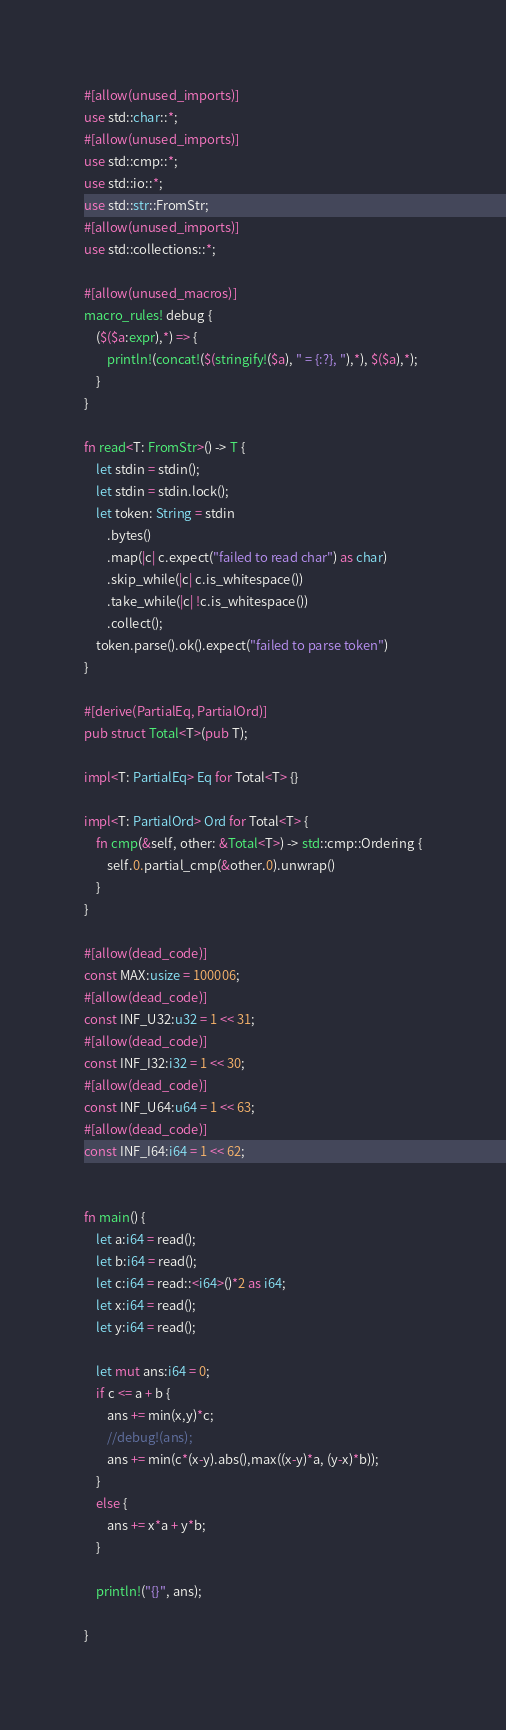Convert code to text. <code><loc_0><loc_0><loc_500><loc_500><_Rust_>#[allow(unused_imports)]
use std::char::*;
#[allow(unused_imports)]
use std::cmp::*;
use std::io::*;
use std::str::FromStr;
#[allow(unused_imports)]
use std::collections::*;

#[allow(unused_macros)]
macro_rules! debug {
    ($($a:expr),*) => {
        println!(concat!($(stringify!($a), " = {:?}, "),*), $($a),*);
    }
}

fn read<T: FromStr>() -> T {
    let stdin = stdin();
    let stdin = stdin.lock();
    let token: String = stdin
        .bytes()
        .map(|c| c.expect("failed to read char") as char)
        .skip_while(|c| c.is_whitespace())
        .take_while(|c| !c.is_whitespace())
        .collect();
    token.parse().ok().expect("failed to parse token")
}

#[derive(PartialEq, PartialOrd)]
pub struct Total<T>(pub T);

impl<T: PartialEq> Eq for Total<T> {}

impl<T: PartialOrd> Ord for Total<T> {
    fn cmp(&self, other: &Total<T>) -> std::cmp::Ordering {
        self.0.partial_cmp(&other.0).unwrap()
    }
}

#[allow(dead_code)]
const MAX:usize = 100006;
#[allow(dead_code)]
const INF_U32:u32 = 1 << 31;
#[allow(dead_code)]
const INF_I32:i32 = 1 << 30;
#[allow(dead_code)]
const INF_U64:u64 = 1 << 63;
#[allow(dead_code)]
const INF_I64:i64 = 1 << 62;


fn main() {
    let a:i64 = read();
    let b:i64 = read();
    let c:i64 = read::<i64>()*2 as i64;
    let x:i64 = read();
    let y:i64 = read();

    let mut ans:i64 = 0;
    if c <= a + b {
        ans += min(x,y)*c;
        //debug!(ans);
        ans += min(c*(x-y).abs(),max((x-y)*a, (y-x)*b));
    }
    else {
        ans += x*a + y*b;
    }

    println!("{}", ans);

}
</code> 